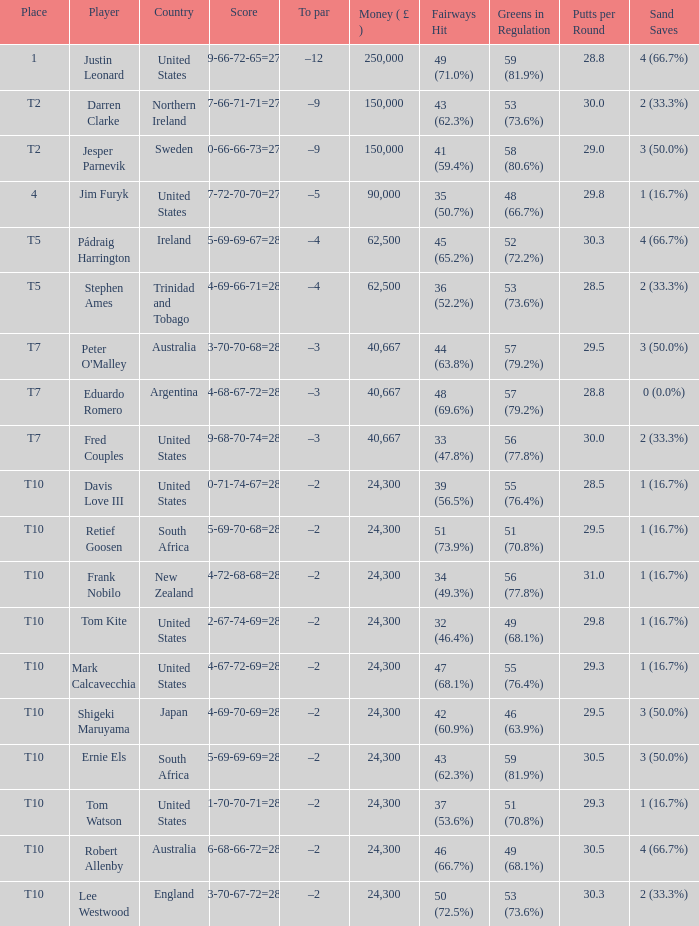How much money has been won by Stephen Ames? 62500.0. 